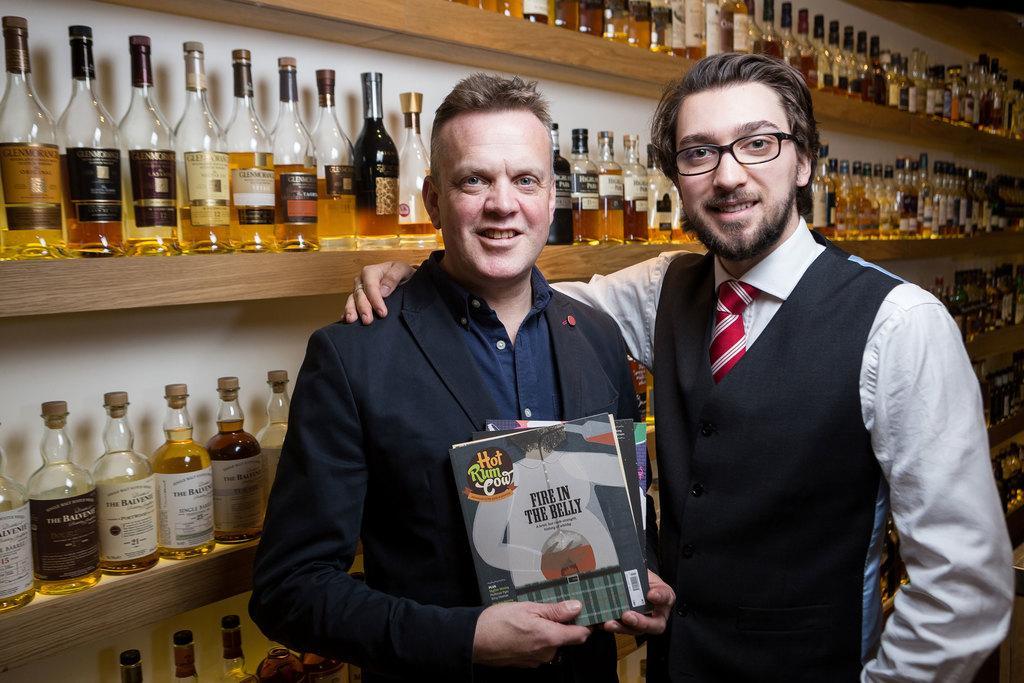How would you summarize this image in a sentence or two? In this picture we can see two men smiling where a man holding books with his hands and at the back of them we can see bottles in racks. 